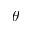<formula> <loc_0><loc_0><loc_500><loc_500>\theta</formula> 